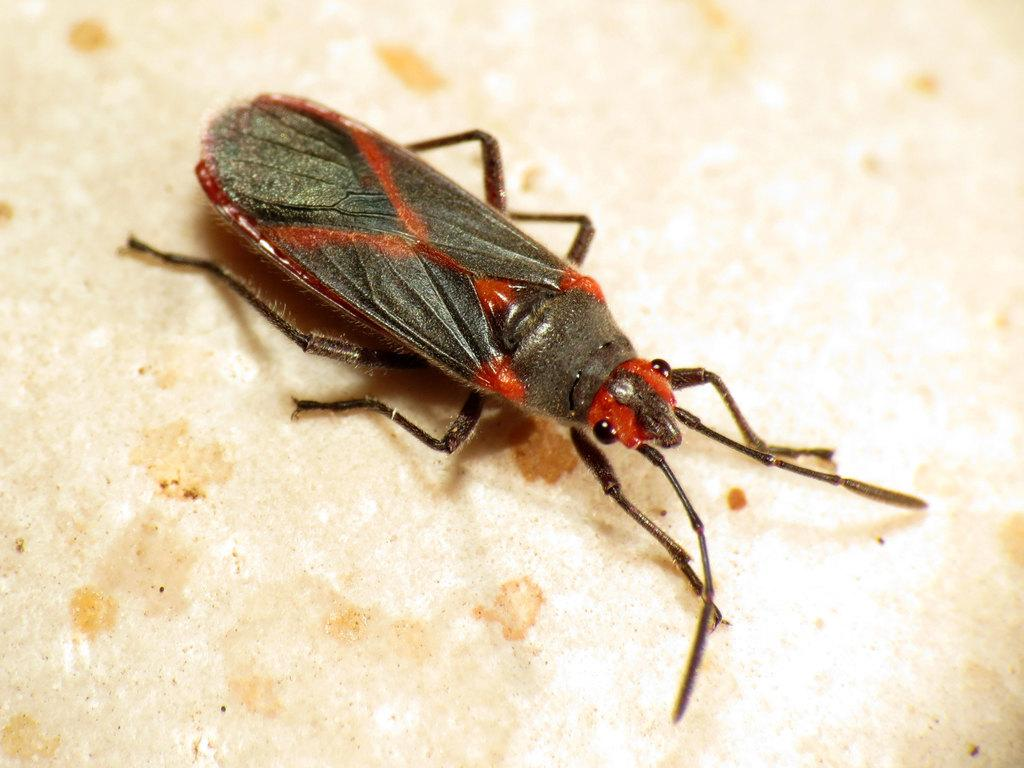What type of creature is present in the image? There is an insect in the image. Where is the insect located in the image? The insect is on a surface. What type of sweater is the insect wearing in the image? There is no sweater present in the image, as insects do not wear clothing. 